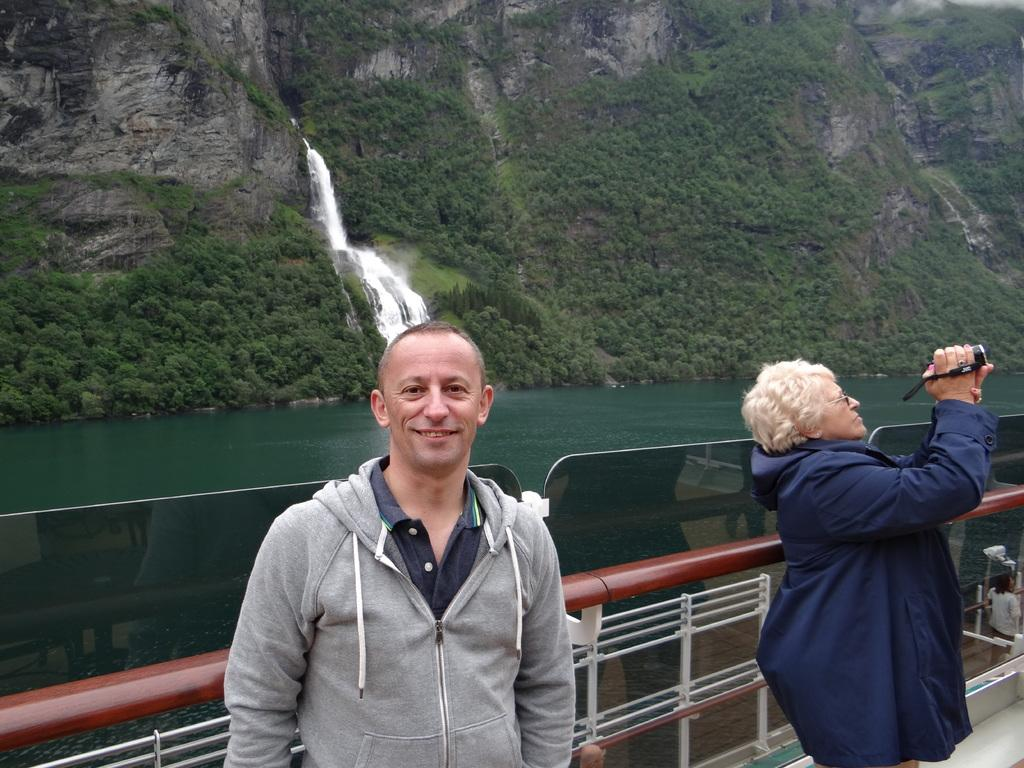What is the person in the foreground of the image doing? The person in the foreground of the image is standing and smiling. What is the other person in the image doing? The other person is standing and holding a camera. What can be seen in the background of the image? There is a waterfall, water, trees, and iron grills visible in the background of the image. What type of stew is being offered to the person holding the camera in the image? There is no stew present in the image, and no one is offering anything to the person holding the camera. 